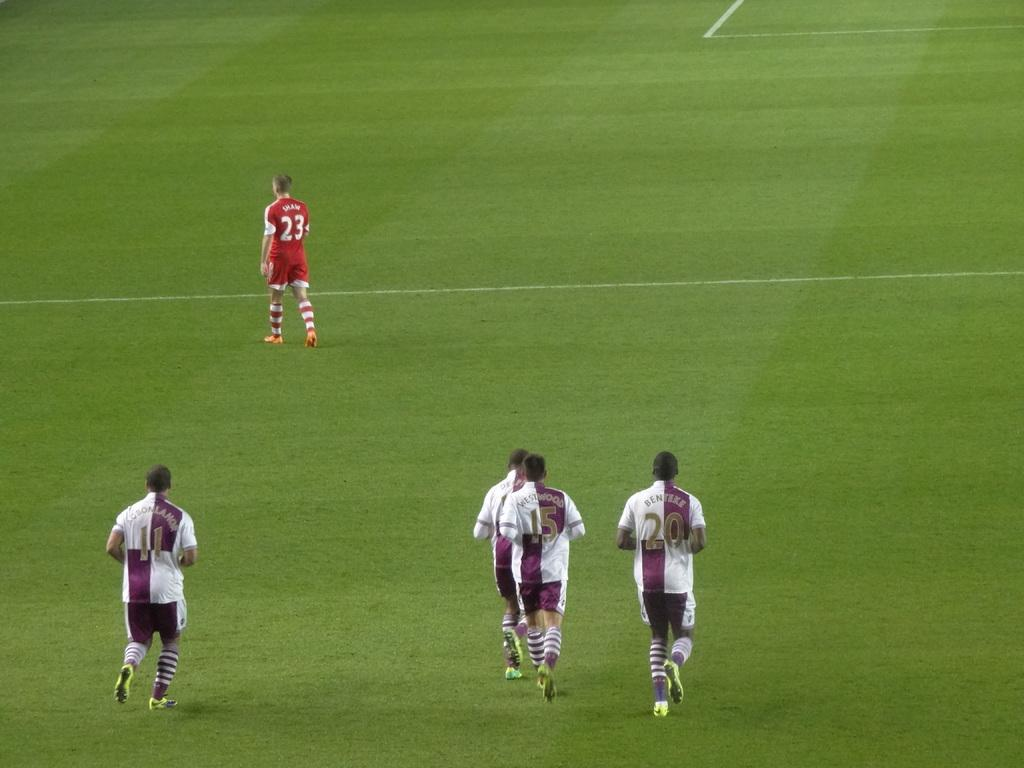How many football players are in the image? There are four football players in the image. What are the football players doing in the image? The football players are running on the ground. Can you describe the other person in the image? The other person is wearing a red color jersey and is walking on the ground. What type of fork can be seen in the hands of the football players in the image? There are no forks present in the image; the football players are running with a ball. How does the love between the football players and the person in the red jersey affect their actions in the image? The image does not provide any information about the emotions or relationships between the individuals, so it is impossible to determine how love might affect their actions. 